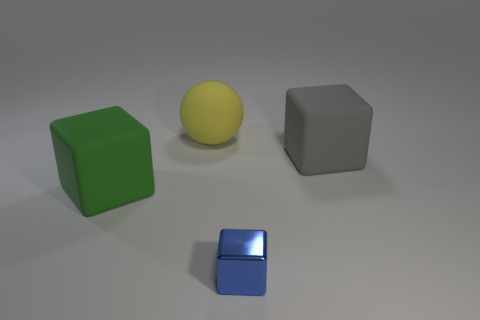What color is the small shiny object that is the same shape as the large gray object?
Your response must be concise. Blue. There is a gray rubber thing that is the same shape as the small metallic object; what is its size?
Offer a very short reply. Large. How many other tiny cubes are the same color as the small shiny block?
Offer a terse response. 0. What number of things are either tiny shiny objects or large brown spheres?
Make the answer very short. 1. What is the yellow thing on the left side of the cube that is to the right of the small shiny block made of?
Your answer should be compact. Rubber. Are there any other green blocks made of the same material as the large green block?
Make the answer very short. No. What is the shape of the object behind the cube that is behind the green matte block that is in front of the yellow ball?
Your response must be concise. Sphere. What is the blue block made of?
Offer a terse response. Metal. What is the color of the big sphere that is the same material as the gray cube?
Your answer should be very brief. Yellow. There is a big rubber object in front of the big gray matte object; is there a small blue shiny object that is to the left of it?
Offer a terse response. No. 